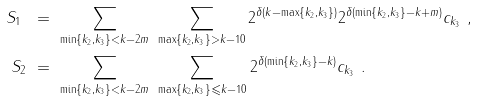<formula> <loc_0><loc_0><loc_500><loc_500>S _ { 1 } \ & = \ \sum _ { \min \{ k _ { 2 } , k _ { 3 } \} < k - 2 m } \ \sum _ { \max \{ k _ { 2 } , k _ { 3 } \} > k - 1 0 } 2 ^ { \delta ( k - \max \{ k _ { 2 } , k _ { 3 } \} ) } 2 ^ { \delta ( \min \{ k _ { 2 } , k _ { 3 } \} - k + m ) } c _ { k _ { 3 } } \ , \\ S _ { 2 } \ & = \ \sum _ { \min \{ k _ { 2 } , k _ { 3 } \} < k - 2 m } \ \sum _ { \max \{ k _ { 2 } , k _ { 3 } \} \leqslant k - 1 0 } 2 ^ { \delta ( \min \{ k _ { 2 } , k _ { 3 } \} - k ) } c _ { k _ { 3 } } \ .</formula> 